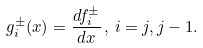<formula> <loc_0><loc_0><loc_500><loc_500>g _ { i } ^ { \pm } ( x ) = \frac { d f _ { i } ^ { \pm } } { d x } \, , \, i = j , j - 1 .</formula> 